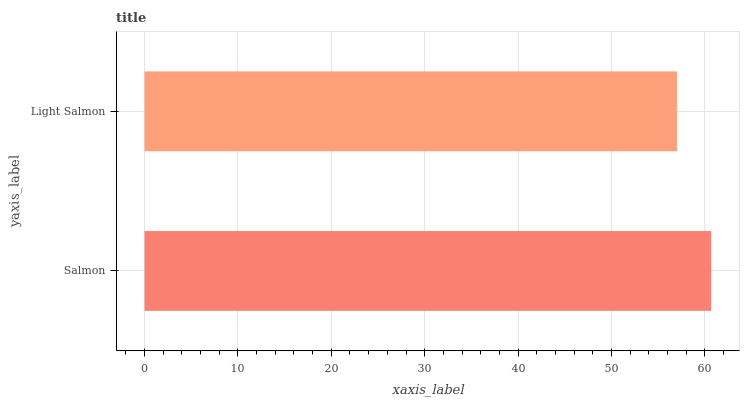Is Light Salmon the minimum?
Answer yes or no. Yes. Is Salmon the maximum?
Answer yes or no. Yes. Is Light Salmon the maximum?
Answer yes or no. No. Is Salmon greater than Light Salmon?
Answer yes or no. Yes. Is Light Salmon less than Salmon?
Answer yes or no. Yes. Is Light Salmon greater than Salmon?
Answer yes or no. No. Is Salmon less than Light Salmon?
Answer yes or no. No. Is Salmon the high median?
Answer yes or no. Yes. Is Light Salmon the low median?
Answer yes or no. Yes. Is Light Salmon the high median?
Answer yes or no. No. Is Salmon the low median?
Answer yes or no. No. 